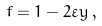<formula> <loc_0><loc_0><loc_500><loc_500>f = 1 - 2 \varepsilon y \, ,</formula> 